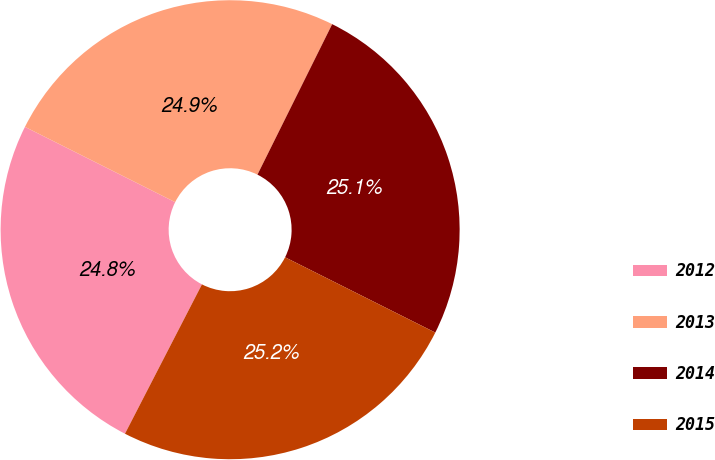<chart> <loc_0><loc_0><loc_500><loc_500><pie_chart><fcel>2012<fcel>2013<fcel>2014<fcel>2015<nl><fcel>24.82%<fcel>24.94%<fcel>25.06%<fcel>25.18%<nl></chart> 